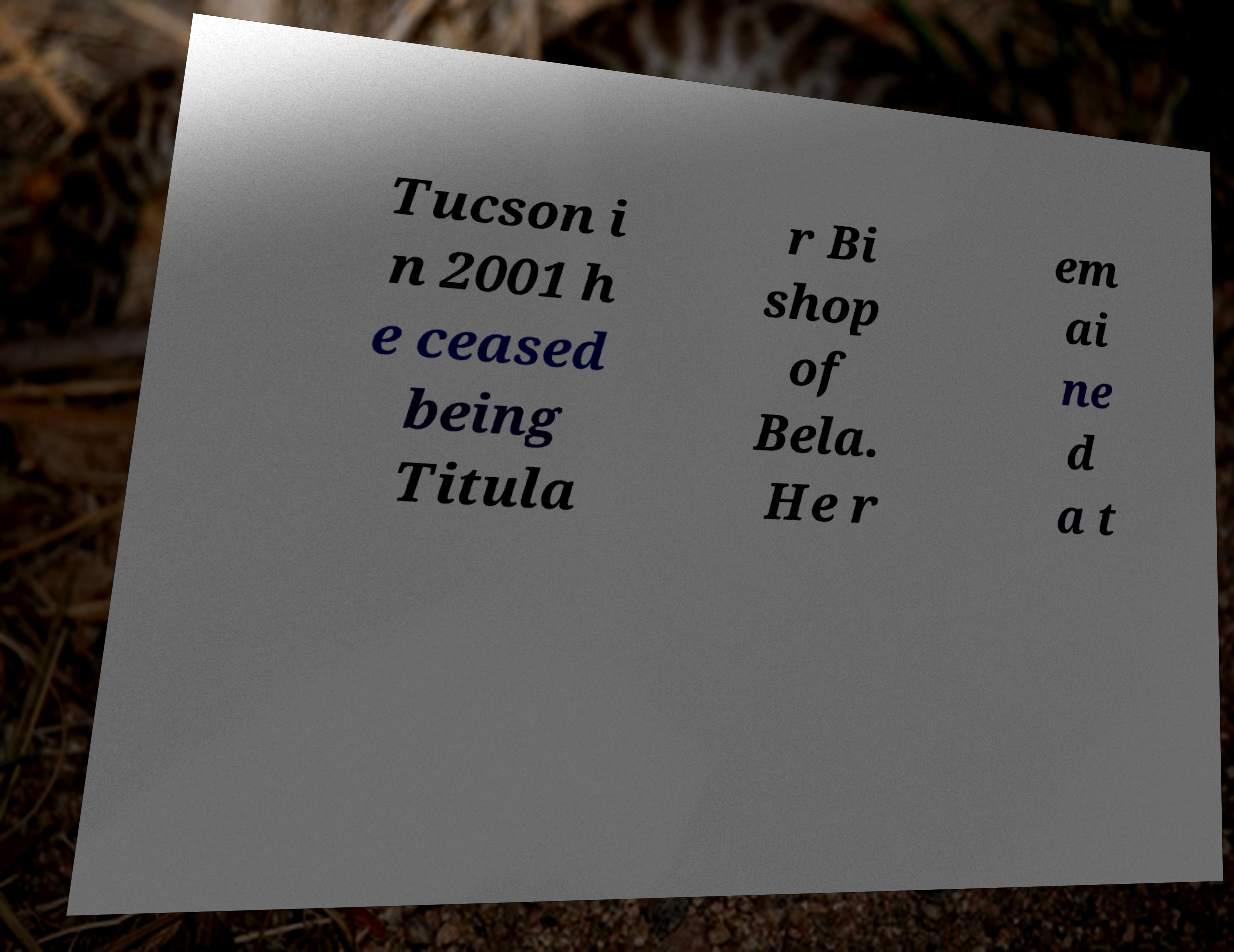What messages or text are displayed in this image? I need them in a readable, typed format. Tucson i n 2001 h e ceased being Titula r Bi shop of Bela. He r em ai ne d a t 